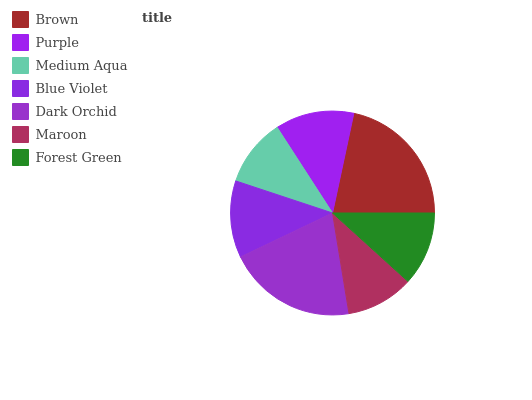Is Maroon the minimum?
Answer yes or no. Yes. Is Brown the maximum?
Answer yes or no. Yes. Is Purple the minimum?
Answer yes or no. No. Is Purple the maximum?
Answer yes or no. No. Is Brown greater than Purple?
Answer yes or no. Yes. Is Purple less than Brown?
Answer yes or no. Yes. Is Purple greater than Brown?
Answer yes or no. No. Is Brown less than Purple?
Answer yes or no. No. Is Blue Violet the high median?
Answer yes or no. Yes. Is Blue Violet the low median?
Answer yes or no. Yes. Is Purple the high median?
Answer yes or no. No. Is Brown the low median?
Answer yes or no. No. 